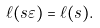Convert formula to latex. <formula><loc_0><loc_0><loc_500><loc_500>\ell ( s \varepsilon ) = \ell ( s ) .</formula> 